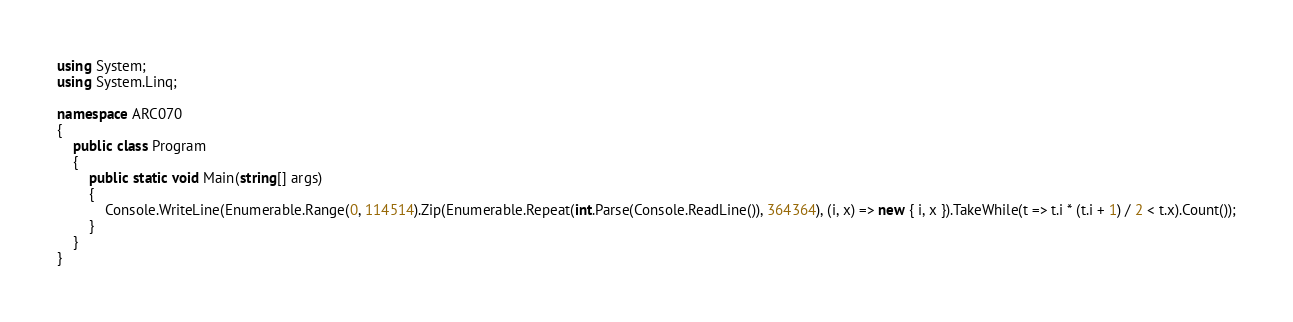<code> <loc_0><loc_0><loc_500><loc_500><_C#_>using System;
using System.Linq;

namespace ARC070
{
    public class Program
    {
        public static void Main(string[] args)
        {
            Console.WriteLine(Enumerable.Range(0, 114514).Zip(Enumerable.Repeat(int.Parse(Console.ReadLine()), 364364), (i, x) => new { i, x }).TakeWhile(t => t.i * (t.i + 1) / 2 < t.x).Count());
        }
    }
}</code> 